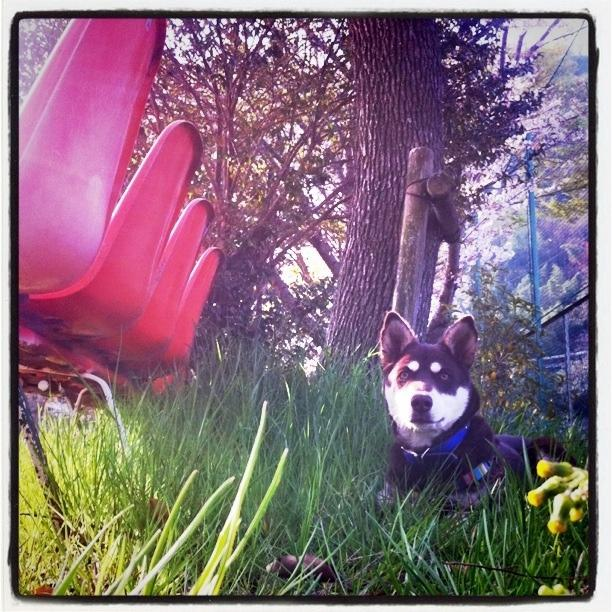What item is in the wrong setting? Please explain your reasoning. chairs. These are indoor chairs. people normally wouldn't sit in them in the grass. 